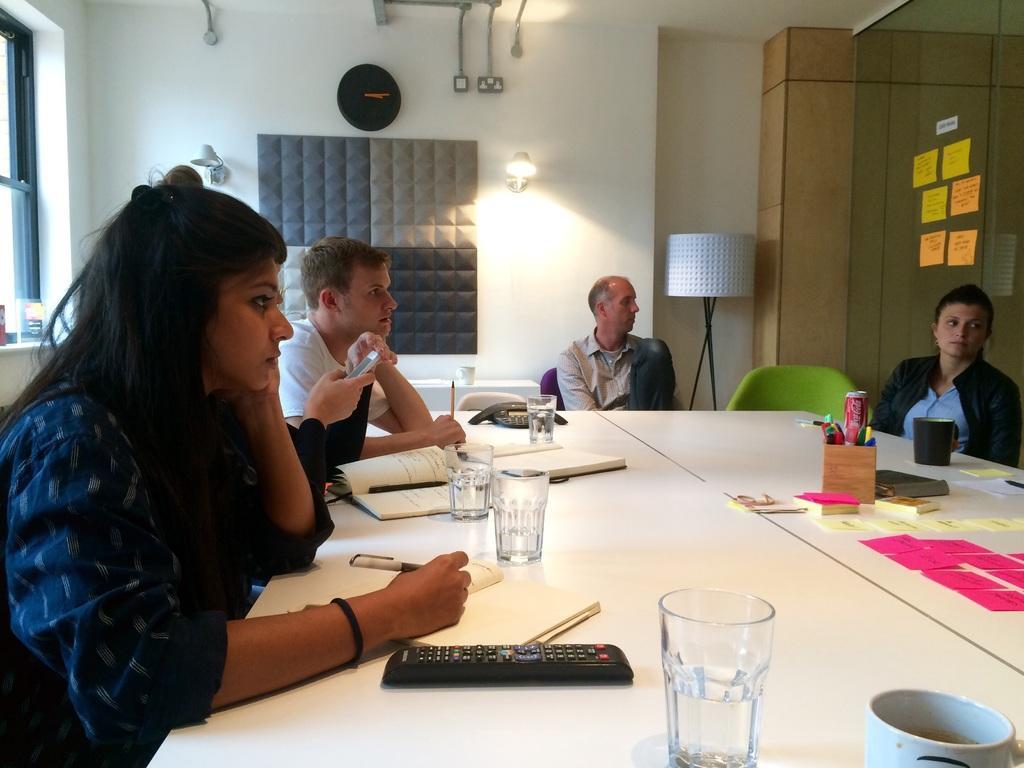Can you describe this image briefly? This picture shows a group of people seated on the chairs and we see few glasses and few books on the table 